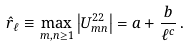<formula> <loc_0><loc_0><loc_500><loc_500>\hat { r } _ { \ell } \equiv \max _ { m , n \geq 1 } \left | U ^ { 2 2 } _ { m n } \right | = a + \frac { b } { \ell ^ { c } } \, .</formula> 